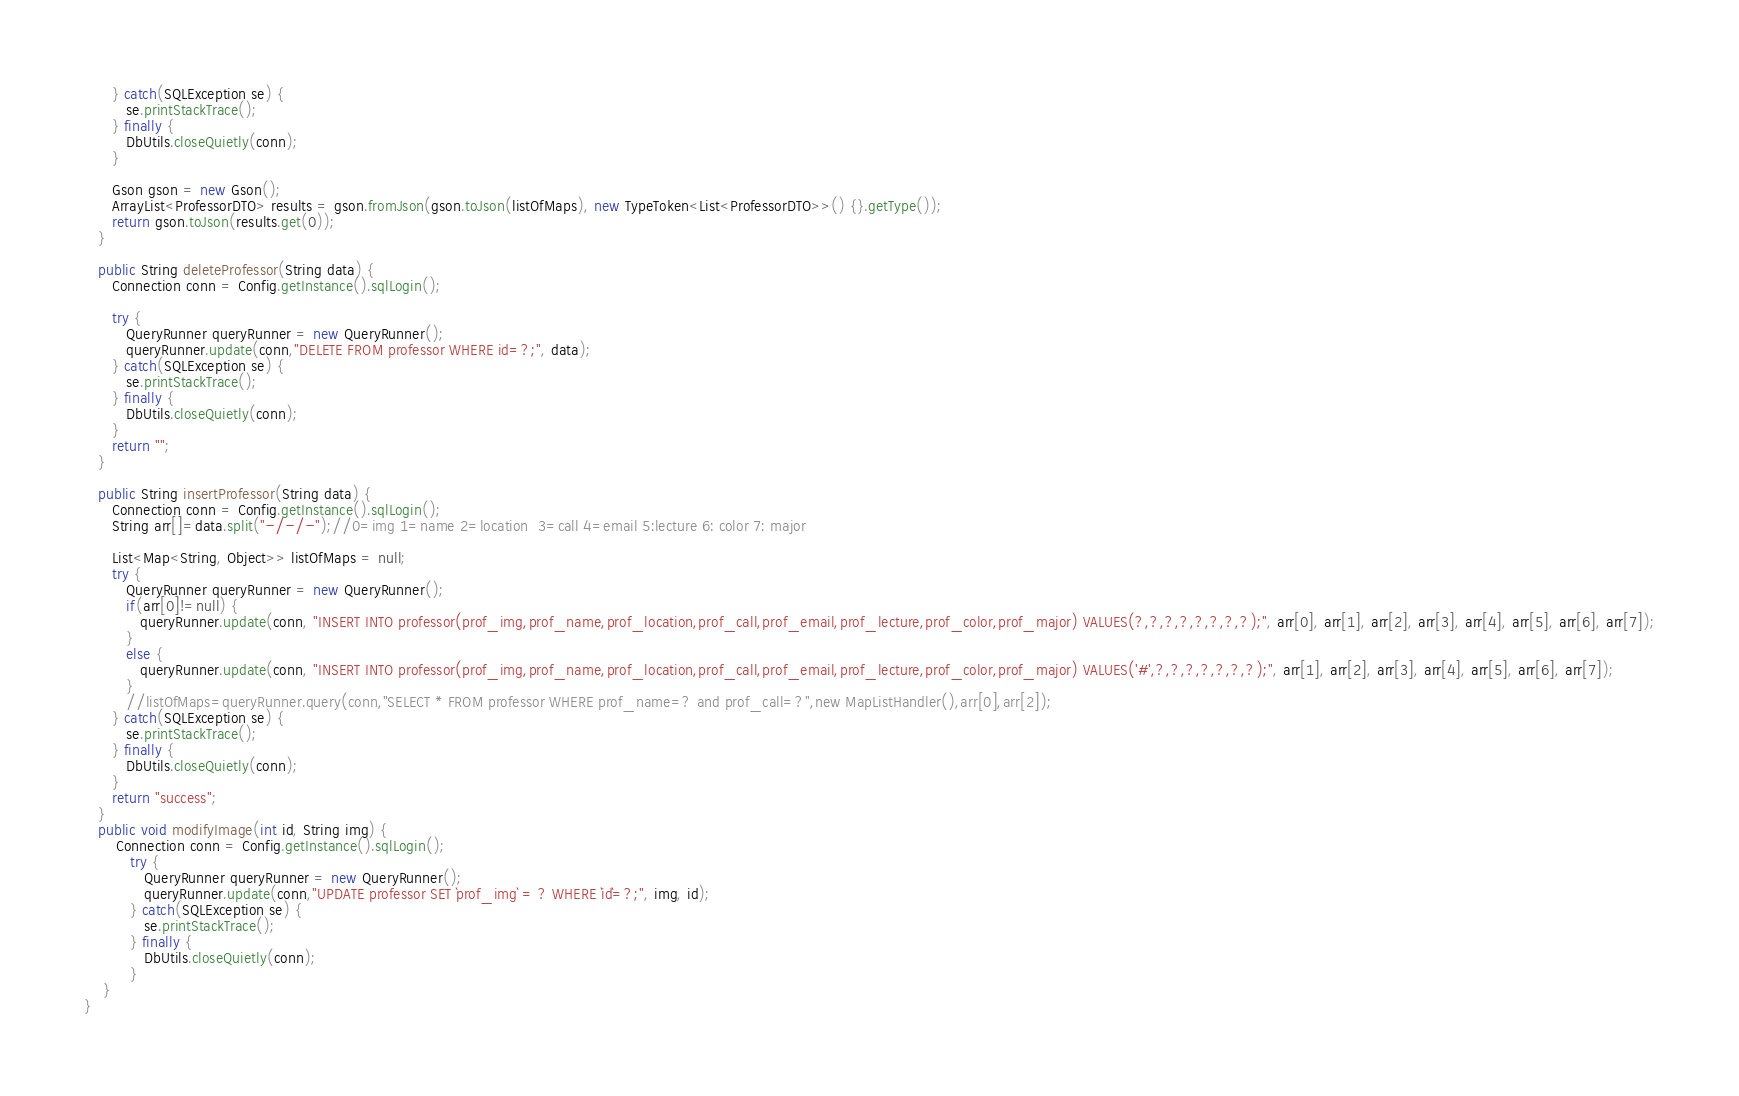Convert code to text. <code><loc_0><loc_0><loc_500><loc_500><_Java_>      } catch(SQLException se) {
         se.printStackTrace();
      } finally {
         DbUtils.closeQuietly(conn);
      }

      Gson gson = new Gson();
      ArrayList<ProfessorDTO> results = gson.fromJson(gson.toJson(listOfMaps), new TypeToken<List<ProfessorDTO>>() {}.getType());
      return gson.toJson(results.get(0));
   }
   
   public String deleteProfessor(String data) {
      Connection conn = Config.getInstance().sqlLogin();
      
      try {
         QueryRunner queryRunner = new QueryRunner();
         queryRunner.update(conn,"DELETE FROM professor WHERE id=?;", data);
      } catch(SQLException se) {
         se.printStackTrace();
      } finally {
         DbUtils.closeQuietly(conn);
      }
      return "";
   }

   public String insertProfessor(String data) {
      Connection conn = Config.getInstance().sqlLogin();
      String arr[]=data.split("-/-/-");//0=img 1=name 2=location  3=call 4=email 5:lecture 6: color 7: major

      List<Map<String, Object>> listOfMaps = null;
      try {
         QueryRunner queryRunner = new QueryRunner();
         if(arr[0]!=null) {
            queryRunner.update(conn, "INSERT INTO professor(prof_img,prof_name,prof_location,prof_call,prof_email,prof_lecture,prof_color,prof_major) VALUES(?,?,?,?,?,?,?,?);", arr[0], arr[1], arr[2], arr[3], arr[4], arr[5], arr[6], arr[7]);
         }
         else {
            queryRunner.update(conn, "INSERT INTO professor(prof_img,prof_name,prof_location,prof_call,prof_email,prof_lecture,prof_color,prof_major) VALUES('#',?,?,?,?,?,?,?);", arr[1], arr[2], arr[3], arr[4], arr[5], arr[6], arr[7]);
         }
         //listOfMaps=queryRunner.query(conn,"SELECT * FROM professor WHERE prof_name=? and prof_call=?",new MapListHandler(),arr[0],arr[2]);
      } catch(SQLException se) {
         se.printStackTrace();
      } finally {
         DbUtils.closeQuietly(conn);
      }
      return "success";
   }
   public void modifyImage(int id, String img) {
	   Connection conn = Config.getInstance().sqlLogin();
	      try {
	         QueryRunner queryRunner = new QueryRunner();
	         queryRunner.update(conn,"UPDATE professor SET `prof_img` = ? WHERE `id`=?;", img, id);
	      } catch(SQLException se) {
	         se.printStackTrace();
	      } finally {
	         DbUtils.closeQuietly(conn);
	      }
   	}
}</code> 